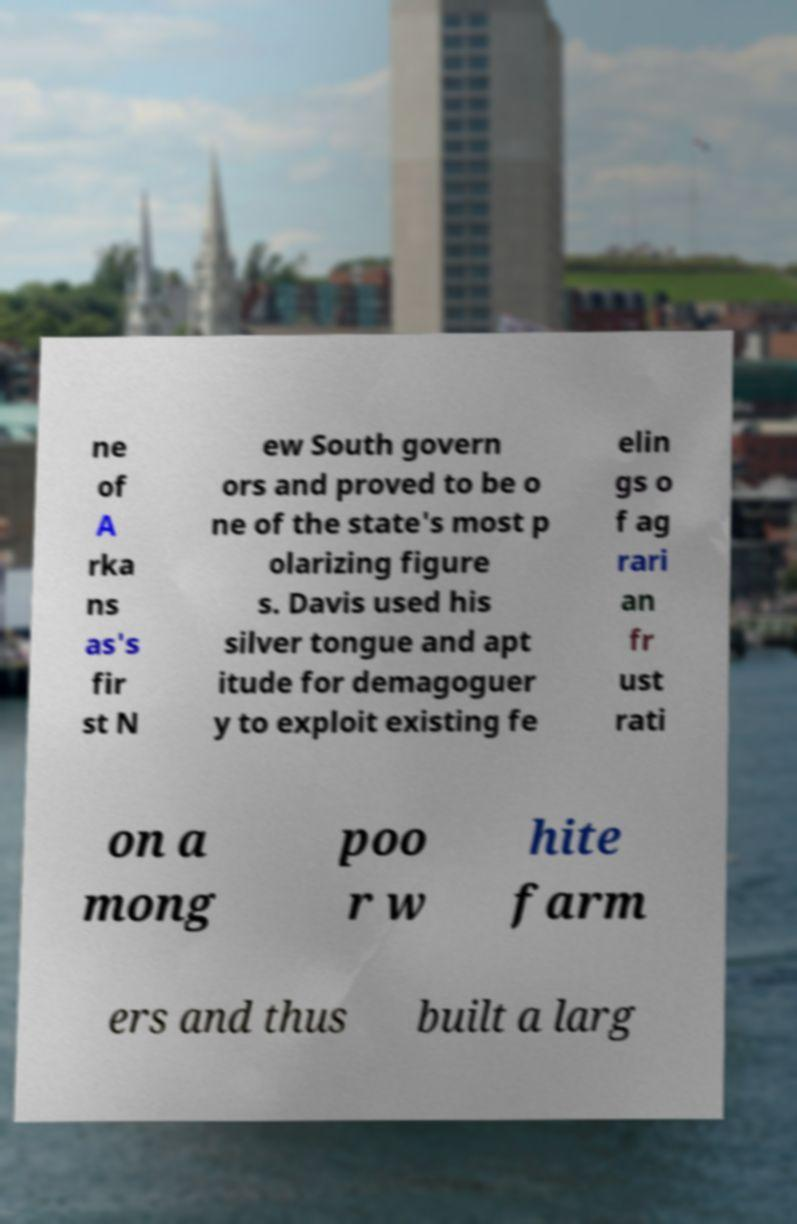Can you accurately transcribe the text from the provided image for me? ne of A rka ns as's fir st N ew South govern ors and proved to be o ne of the state's most p olarizing figure s. Davis used his silver tongue and apt itude for demagoguer y to exploit existing fe elin gs o f ag rari an fr ust rati on a mong poo r w hite farm ers and thus built a larg 